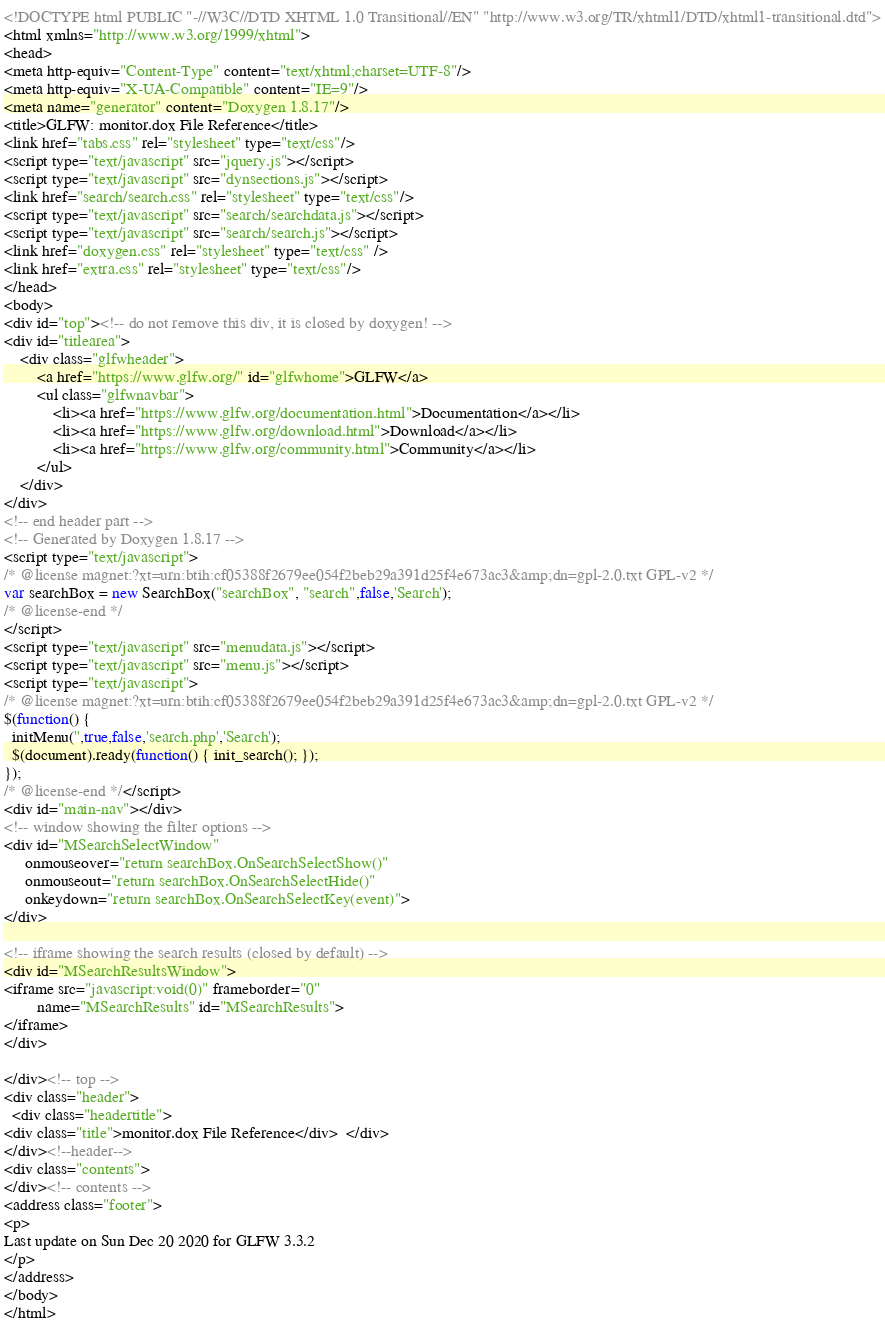<code> <loc_0><loc_0><loc_500><loc_500><_HTML_><!DOCTYPE html PUBLIC "-//W3C//DTD XHTML 1.0 Transitional//EN" "http://www.w3.org/TR/xhtml1/DTD/xhtml1-transitional.dtd">
<html xmlns="http://www.w3.org/1999/xhtml">
<head>
<meta http-equiv="Content-Type" content="text/xhtml;charset=UTF-8"/>
<meta http-equiv="X-UA-Compatible" content="IE=9"/>
<meta name="generator" content="Doxygen 1.8.17"/>
<title>GLFW: monitor.dox File Reference</title>
<link href="tabs.css" rel="stylesheet" type="text/css"/>
<script type="text/javascript" src="jquery.js"></script>
<script type="text/javascript" src="dynsections.js"></script>
<link href="search/search.css" rel="stylesheet" type="text/css"/>
<script type="text/javascript" src="search/searchdata.js"></script>
<script type="text/javascript" src="search/search.js"></script>
<link href="doxygen.css" rel="stylesheet" type="text/css" />
<link href="extra.css" rel="stylesheet" type="text/css"/>
</head>
<body>
<div id="top"><!-- do not remove this div, it is closed by doxygen! -->
<div id="titlearea">
	<div class="glfwheader">
		<a href="https://www.glfw.org/" id="glfwhome">GLFW</a>
		<ul class="glfwnavbar">
			<li><a href="https://www.glfw.org/documentation.html">Documentation</a></li>
			<li><a href="https://www.glfw.org/download.html">Download</a></li>
			<li><a href="https://www.glfw.org/community.html">Community</a></li>
		</ul>
	</div>
</div>
<!-- end header part -->
<!-- Generated by Doxygen 1.8.17 -->
<script type="text/javascript">
/* @license magnet:?xt=urn:btih:cf05388f2679ee054f2beb29a391d25f4e673ac3&amp;dn=gpl-2.0.txt GPL-v2 */
var searchBox = new SearchBox("searchBox", "search",false,'Search');
/* @license-end */
</script>
<script type="text/javascript" src="menudata.js"></script>
<script type="text/javascript" src="menu.js"></script>
<script type="text/javascript">
/* @license magnet:?xt=urn:btih:cf05388f2679ee054f2beb29a391d25f4e673ac3&amp;dn=gpl-2.0.txt GPL-v2 */
$(function() {
  initMenu('',true,false,'search.php','Search');
  $(document).ready(function() { init_search(); });
});
/* @license-end */</script>
<div id="main-nav"></div>
<!-- window showing the filter options -->
<div id="MSearchSelectWindow"
     onmouseover="return searchBox.OnSearchSelectShow()"
     onmouseout="return searchBox.OnSearchSelectHide()"
     onkeydown="return searchBox.OnSearchSelectKey(event)">
</div>

<!-- iframe showing the search results (closed by default) -->
<div id="MSearchResultsWindow">
<iframe src="javascript:void(0)" frameborder="0" 
        name="MSearchResults" id="MSearchResults">
</iframe>
</div>

</div><!-- top -->
<div class="header">
  <div class="headertitle">
<div class="title">monitor.dox File Reference</div>  </div>
</div><!--header-->
<div class="contents">
</div><!-- contents -->
<address class="footer">
<p>
Last update on Sun Dec 20 2020 for GLFW 3.3.2
</p>
</address>
</body>
</html>
</code> 